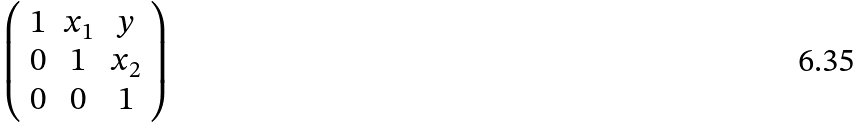Convert formula to latex. <formula><loc_0><loc_0><loc_500><loc_500>\left ( \begin{array} { c c c } { 1 } & { { x _ { 1 } } } & { y } \\ { 0 } & { 1 } & { { x _ { 2 } } } \\ { 0 } & { 0 } & { 1 } \end{array} \right )</formula> 